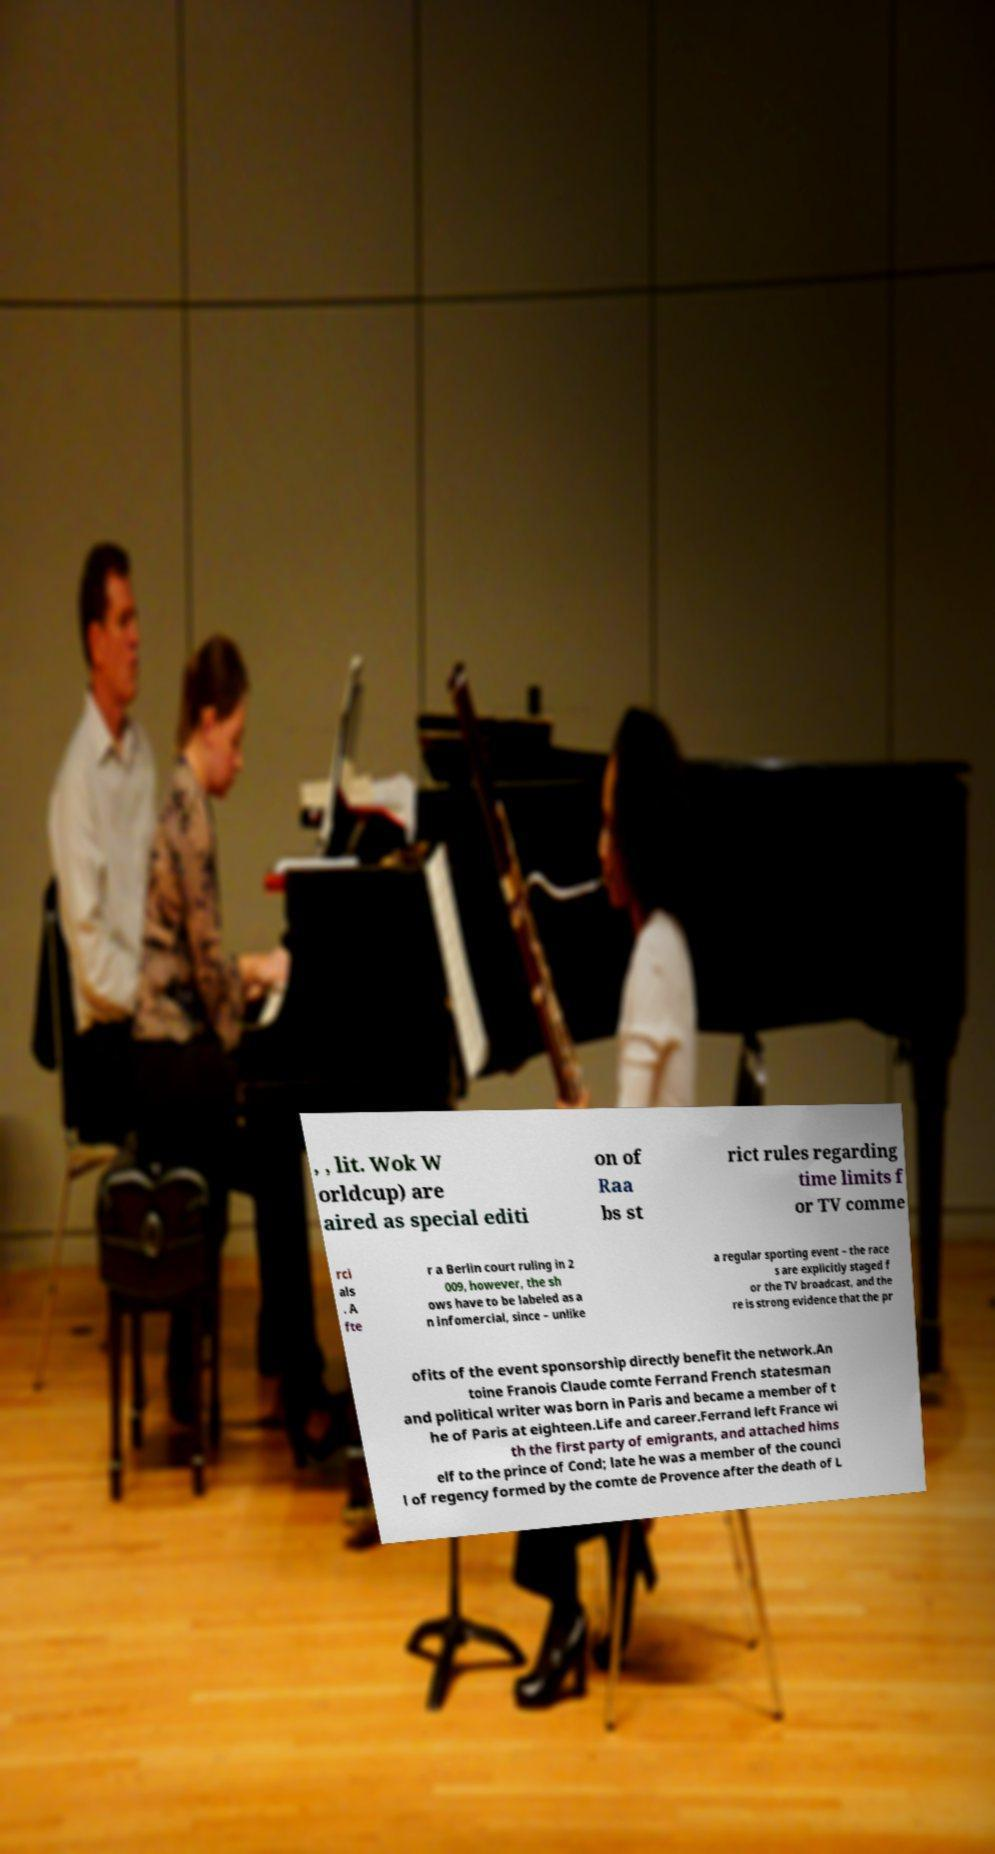Please read and relay the text visible in this image. What does it say? , , lit. Wok W orldcup) are aired as special editi on of Raa bs st rict rules regarding time limits f or TV comme rci als . A fte r a Berlin court ruling in 2 009, however, the sh ows have to be labeled as a n infomercial, since – unlike a regular sporting event – the race s are explicitly staged f or the TV broadcast, and the re is strong evidence that the pr ofits of the event sponsorship directly benefit the network.An toine Franois Claude comte Ferrand French statesman and political writer was born in Paris and became a member of t he of Paris at eighteen.Life and career.Ferrand left France wi th the first party of emigrants, and attached hims elf to the prince of Cond; late he was a member of the counci l of regency formed by the comte de Provence after the death of L 